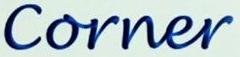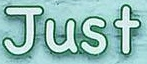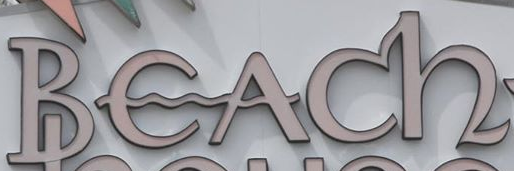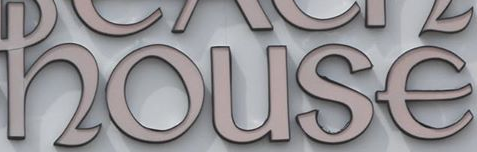What words are shown in these images in order, separated by a semicolon? Corner; Just; Beach; house 